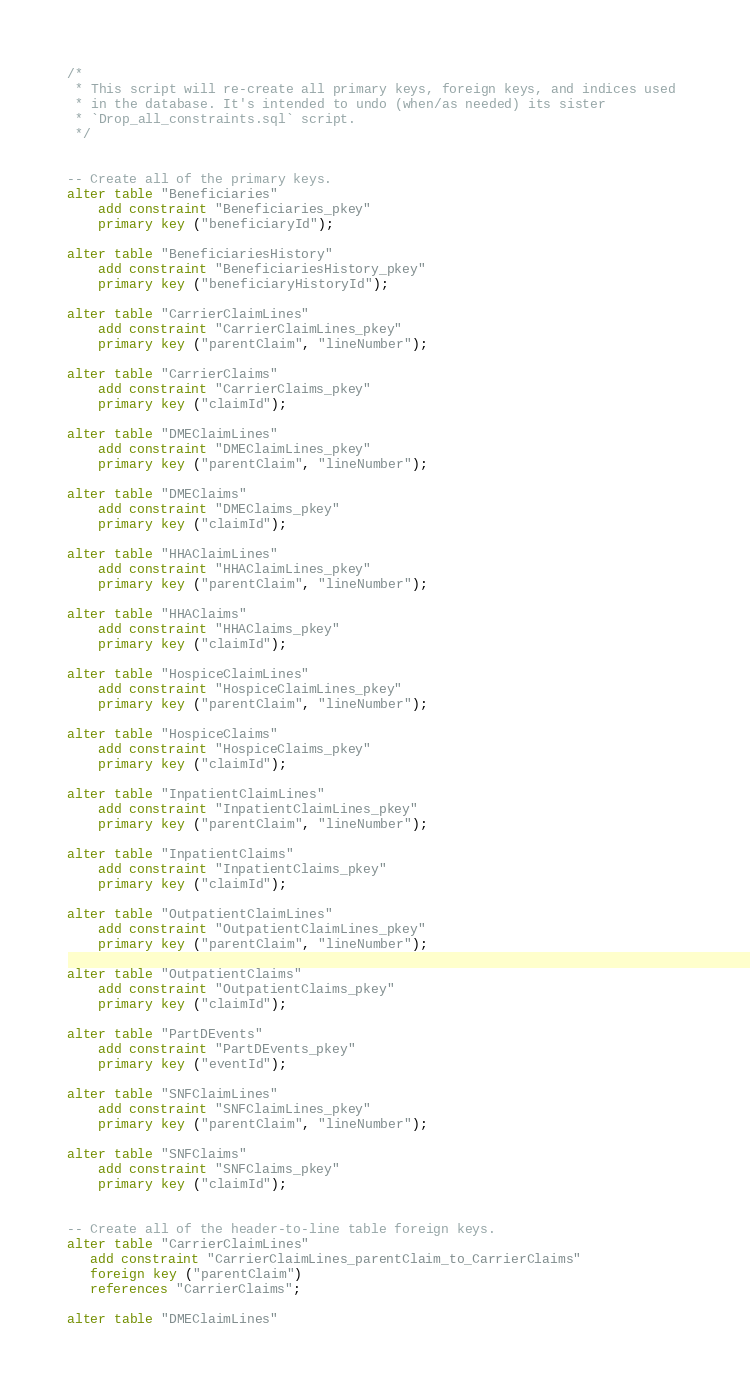<code> <loc_0><loc_0><loc_500><loc_500><_SQL_>/*
 * This script will re-create all primary keys, foreign keys, and indices used 
 * in the database. It's intended to undo (when/as needed) its sister 
 * `Drop_all_constraints.sql` script.
 */


-- Create all of the primary keys.
alter table "Beneficiaries" 
    add constraint "Beneficiaries_pkey" 
    primary key ("beneficiaryId");

alter table "BeneficiariesHistory"
    add constraint "BeneficiariesHistory_pkey"
    primary key ("beneficiaryHistoryId");

alter table "CarrierClaimLines" 
    add constraint "CarrierClaimLines_pkey" 
    primary key ("parentClaim", "lineNumber");

alter table "CarrierClaims" 
    add constraint "CarrierClaims_pkey" 
    primary key ("claimId");

alter table "DMEClaimLines" 
    add constraint "DMEClaimLines_pkey" 
    primary key ("parentClaim", "lineNumber");

alter table "DMEClaims" 
    add constraint "DMEClaims_pkey" 
    primary key ("claimId");

alter table "HHAClaimLines" 
    add constraint "HHAClaimLines_pkey" 
    primary key ("parentClaim", "lineNumber");

alter table "HHAClaims" 
    add constraint "HHAClaims_pkey" 
    primary key ("claimId");

alter table "HospiceClaimLines" 
    add constraint "HospiceClaimLines_pkey" 
    primary key ("parentClaim", "lineNumber");

alter table "HospiceClaims" 
    add constraint "HospiceClaims_pkey" 
    primary key ("claimId");

alter table "InpatientClaimLines" 
    add constraint "InpatientClaimLines_pkey" 
    primary key ("parentClaim", "lineNumber");

alter table "InpatientClaims" 
    add constraint "InpatientClaims_pkey" 
    primary key ("claimId");

alter table "OutpatientClaimLines" 
    add constraint "OutpatientClaimLines_pkey" 
    primary key ("parentClaim", "lineNumber");

alter table "OutpatientClaims" 
    add constraint "OutpatientClaims_pkey" 
    primary key ("claimId");

alter table "PartDEvents" 
    add constraint "PartDEvents_pkey" 
    primary key ("eventId");

alter table "SNFClaimLines" 
    add constraint "SNFClaimLines_pkey" 
    primary key ("parentClaim", "lineNumber");

alter table "SNFClaims" 
    add constraint "SNFClaims_pkey" 
    primary key ("claimId");


-- Create all of the header-to-line table foreign keys.
alter table "CarrierClaimLines" 
   add constraint "CarrierClaimLines_parentClaim_to_CarrierClaims" 
   foreign key ("parentClaim") 
   references "CarrierClaims";

alter table "DMEClaimLines" </code> 